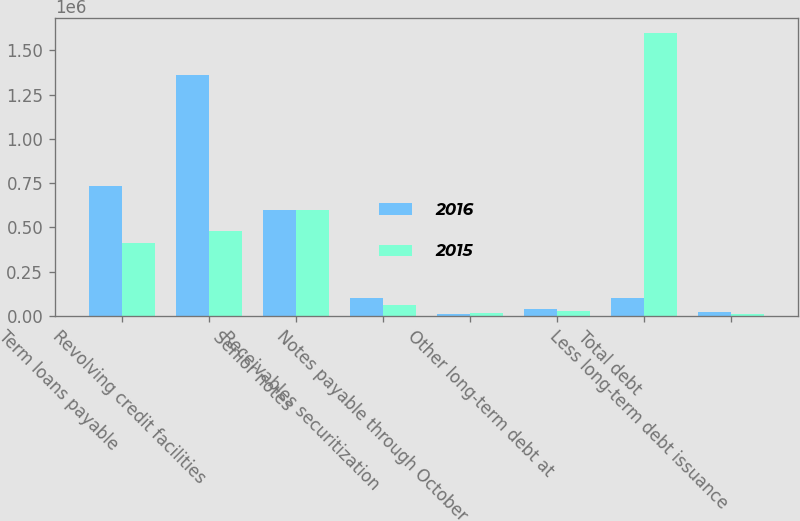Convert chart to OTSL. <chart><loc_0><loc_0><loc_500><loc_500><stacked_bar_chart><ecel><fcel>Term loans payable<fcel>Revolving credit facilities<fcel>Senior notes<fcel>Receivables securitization<fcel>Notes payable through October<fcel>Other long-term debt at<fcel>Total debt<fcel>Less long-term debt issuance<nl><fcel>2016<fcel>732684<fcel>1.35822e+06<fcel>600000<fcel>100000<fcel>11808<fcel>37125<fcel>100000<fcel>21611<nl><fcel>2015<fcel>410625<fcel>480481<fcel>600000<fcel>63000<fcel>16104<fcel>29485<fcel>1.5997e+06<fcel>13533<nl></chart> 